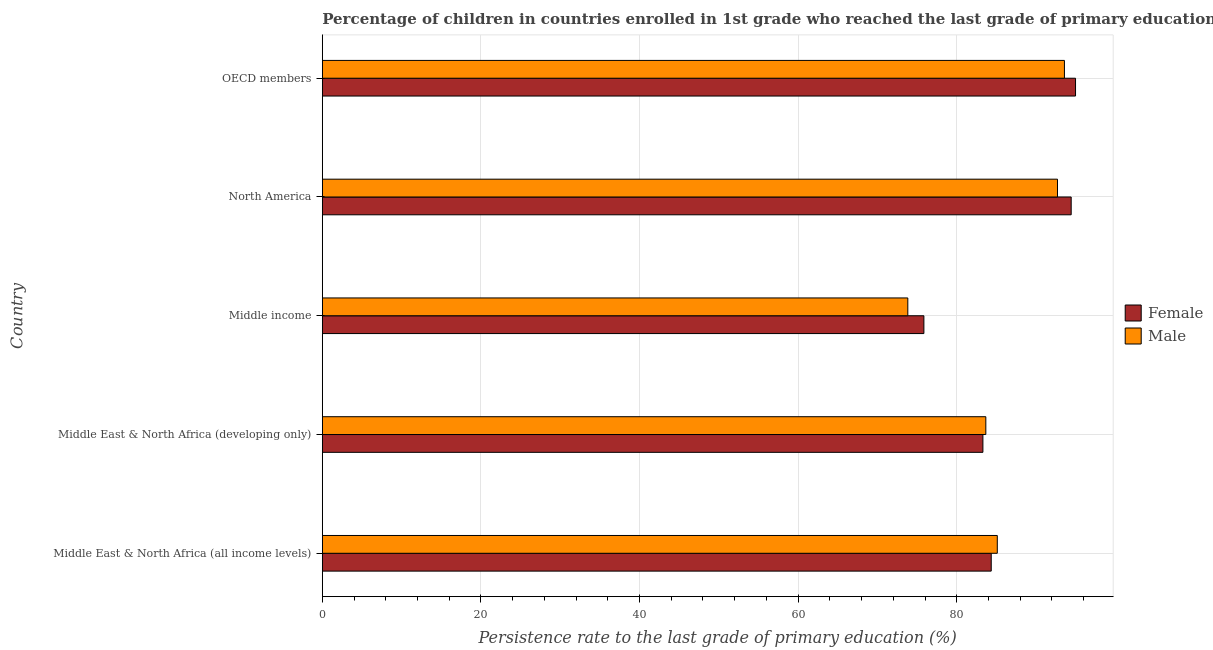How many different coloured bars are there?
Your response must be concise. 2. How many groups of bars are there?
Ensure brevity in your answer.  5. Are the number of bars per tick equal to the number of legend labels?
Your answer should be very brief. Yes. Are the number of bars on each tick of the Y-axis equal?
Your response must be concise. Yes. How many bars are there on the 5th tick from the top?
Provide a short and direct response. 2. In how many cases, is the number of bars for a given country not equal to the number of legend labels?
Make the answer very short. 0. What is the persistence rate of male students in Middle East & North Africa (developing only)?
Your answer should be compact. 83.66. Across all countries, what is the maximum persistence rate of male students?
Your answer should be compact. 93.58. Across all countries, what is the minimum persistence rate of male students?
Offer a terse response. 73.83. In which country was the persistence rate of male students maximum?
Your response must be concise. OECD members. What is the total persistence rate of female students in the graph?
Make the answer very short. 432.91. What is the difference between the persistence rate of male students in North America and that in OECD members?
Your response must be concise. -0.88. What is the difference between the persistence rate of female students in Middle income and the persistence rate of male students in North America?
Your response must be concise. -16.85. What is the average persistence rate of female students per country?
Your answer should be very brief. 86.58. What is the difference between the persistence rate of male students and persistence rate of female students in OECD members?
Ensure brevity in your answer.  -1.4. What is the ratio of the persistence rate of female students in Middle income to that in OECD members?
Give a very brief answer. 0.8. Is the difference between the persistence rate of female students in Middle East & North Africa (developing only) and North America greater than the difference between the persistence rate of male students in Middle East & North Africa (developing only) and North America?
Offer a very short reply. No. What is the difference between the highest and the lowest persistence rate of male students?
Your response must be concise. 19.75. In how many countries, is the persistence rate of female students greater than the average persistence rate of female students taken over all countries?
Your answer should be very brief. 2. What does the 1st bar from the top in Middle income represents?
Provide a short and direct response. Male. What does the 2nd bar from the bottom in Middle income represents?
Provide a succinct answer. Male. Are all the bars in the graph horizontal?
Provide a succinct answer. Yes. How many countries are there in the graph?
Ensure brevity in your answer.  5. What is the difference between two consecutive major ticks on the X-axis?
Ensure brevity in your answer.  20. Does the graph contain any zero values?
Make the answer very short. No. Does the graph contain grids?
Offer a terse response. Yes. How are the legend labels stacked?
Offer a terse response. Vertical. What is the title of the graph?
Your answer should be compact. Percentage of children in countries enrolled in 1st grade who reached the last grade of primary education. Does "Non-resident workers" appear as one of the legend labels in the graph?
Offer a terse response. No. What is the label or title of the X-axis?
Offer a very short reply. Persistence rate to the last grade of primary education (%). What is the label or title of the Y-axis?
Your response must be concise. Country. What is the Persistence rate to the last grade of primary education (%) in Female in Middle East & North Africa (all income levels)?
Keep it short and to the point. 84.35. What is the Persistence rate to the last grade of primary education (%) of Male in Middle East & North Africa (all income levels)?
Provide a succinct answer. 85.11. What is the Persistence rate to the last grade of primary education (%) of Female in Middle East & North Africa (developing only)?
Make the answer very short. 83.3. What is the Persistence rate to the last grade of primary education (%) in Male in Middle East & North Africa (developing only)?
Make the answer very short. 83.66. What is the Persistence rate to the last grade of primary education (%) of Female in Middle income?
Provide a short and direct response. 75.86. What is the Persistence rate to the last grade of primary education (%) of Male in Middle income?
Provide a short and direct response. 73.83. What is the Persistence rate to the last grade of primary education (%) in Female in North America?
Offer a very short reply. 94.43. What is the Persistence rate to the last grade of primary education (%) of Male in North America?
Make the answer very short. 92.7. What is the Persistence rate to the last grade of primary education (%) in Female in OECD members?
Provide a short and direct response. 94.98. What is the Persistence rate to the last grade of primary education (%) of Male in OECD members?
Keep it short and to the point. 93.58. Across all countries, what is the maximum Persistence rate to the last grade of primary education (%) in Female?
Offer a terse response. 94.98. Across all countries, what is the maximum Persistence rate to the last grade of primary education (%) of Male?
Make the answer very short. 93.58. Across all countries, what is the minimum Persistence rate to the last grade of primary education (%) of Female?
Ensure brevity in your answer.  75.86. Across all countries, what is the minimum Persistence rate to the last grade of primary education (%) in Male?
Offer a very short reply. 73.83. What is the total Persistence rate to the last grade of primary education (%) of Female in the graph?
Offer a terse response. 432.91. What is the total Persistence rate to the last grade of primary education (%) in Male in the graph?
Ensure brevity in your answer.  428.89. What is the difference between the Persistence rate to the last grade of primary education (%) in Female in Middle East & North Africa (all income levels) and that in Middle East & North Africa (developing only)?
Make the answer very short. 1.05. What is the difference between the Persistence rate to the last grade of primary education (%) in Male in Middle East & North Africa (all income levels) and that in Middle East & North Africa (developing only)?
Ensure brevity in your answer.  1.45. What is the difference between the Persistence rate to the last grade of primary education (%) in Female in Middle East & North Africa (all income levels) and that in Middle income?
Keep it short and to the point. 8.49. What is the difference between the Persistence rate to the last grade of primary education (%) of Male in Middle East & North Africa (all income levels) and that in Middle income?
Keep it short and to the point. 11.28. What is the difference between the Persistence rate to the last grade of primary education (%) in Female in Middle East & North Africa (all income levels) and that in North America?
Provide a short and direct response. -10.08. What is the difference between the Persistence rate to the last grade of primary education (%) of Male in Middle East & North Africa (all income levels) and that in North America?
Offer a very short reply. -7.59. What is the difference between the Persistence rate to the last grade of primary education (%) of Female in Middle East & North Africa (all income levels) and that in OECD members?
Offer a very short reply. -10.63. What is the difference between the Persistence rate to the last grade of primary education (%) in Male in Middle East & North Africa (all income levels) and that in OECD members?
Offer a very short reply. -8.47. What is the difference between the Persistence rate to the last grade of primary education (%) in Female in Middle East & North Africa (developing only) and that in Middle income?
Your response must be concise. 7.44. What is the difference between the Persistence rate to the last grade of primary education (%) of Male in Middle East & North Africa (developing only) and that in Middle income?
Offer a terse response. 9.84. What is the difference between the Persistence rate to the last grade of primary education (%) of Female in Middle East & North Africa (developing only) and that in North America?
Ensure brevity in your answer.  -11.13. What is the difference between the Persistence rate to the last grade of primary education (%) of Male in Middle East & North Africa (developing only) and that in North America?
Offer a very short reply. -9.04. What is the difference between the Persistence rate to the last grade of primary education (%) of Female in Middle East & North Africa (developing only) and that in OECD members?
Offer a very short reply. -11.68. What is the difference between the Persistence rate to the last grade of primary education (%) of Male in Middle East & North Africa (developing only) and that in OECD members?
Offer a terse response. -9.91. What is the difference between the Persistence rate to the last grade of primary education (%) in Female in Middle income and that in North America?
Provide a succinct answer. -18.57. What is the difference between the Persistence rate to the last grade of primary education (%) of Male in Middle income and that in North America?
Provide a succinct answer. -18.87. What is the difference between the Persistence rate to the last grade of primary education (%) in Female in Middle income and that in OECD members?
Give a very brief answer. -19.12. What is the difference between the Persistence rate to the last grade of primary education (%) in Male in Middle income and that in OECD members?
Provide a succinct answer. -19.75. What is the difference between the Persistence rate to the last grade of primary education (%) in Female in North America and that in OECD members?
Ensure brevity in your answer.  -0.55. What is the difference between the Persistence rate to the last grade of primary education (%) of Male in North America and that in OECD members?
Make the answer very short. -0.88. What is the difference between the Persistence rate to the last grade of primary education (%) in Female in Middle East & North Africa (all income levels) and the Persistence rate to the last grade of primary education (%) in Male in Middle East & North Africa (developing only)?
Provide a succinct answer. 0.68. What is the difference between the Persistence rate to the last grade of primary education (%) in Female in Middle East & North Africa (all income levels) and the Persistence rate to the last grade of primary education (%) in Male in Middle income?
Offer a very short reply. 10.52. What is the difference between the Persistence rate to the last grade of primary education (%) in Female in Middle East & North Africa (all income levels) and the Persistence rate to the last grade of primary education (%) in Male in North America?
Your response must be concise. -8.36. What is the difference between the Persistence rate to the last grade of primary education (%) in Female in Middle East & North Africa (all income levels) and the Persistence rate to the last grade of primary education (%) in Male in OECD members?
Make the answer very short. -9.23. What is the difference between the Persistence rate to the last grade of primary education (%) of Female in Middle East & North Africa (developing only) and the Persistence rate to the last grade of primary education (%) of Male in Middle income?
Offer a very short reply. 9.47. What is the difference between the Persistence rate to the last grade of primary education (%) of Female in Middle East & North Africa (developing only) and the Persistence rate to the last grade of primary education (%) of Male in North America?
Make the answer very short. -9.41. What is the difference between the Persistence rate to the last grade of primary education (%) of Female in Middle East & North Africa (developing only) and the Persistence rate to the last grade of primary education (%) of Male in OECD members?
Provide a succinct answer. -10.28. What is the difference between the Persistence rate to the last grade of primary education (%) of Female in Middle income and the Persistence rate to the last grade of primary education (%) of Male in North America?
Your answer should be very brief. -16.85. What is the difference between the Persistence rate to the last grade of primary education (%) in Female in Middle income and the Persistence rate to the last grade of primary education (%) in Male in OECD members?
Offer a very short reply. -17.72. What is the difference between the Persistence rate to the last grade of primary education (%) of Female in North America and the Persistence rate to the last grade of primary education (%) of Male in OECD members?
Provide a succinct answer. 0.85. What is the average Persistence rate to the last grade of primary education (%) in Female per country?
Provide a short and direct response. 86.58. What is the average Persistence rate to the last grade of primary education (%) in Male per country?
Provide a succinct answer. 85.78. What is the difference between the Persistence rate to the last grade of primary education (%) of Female and Persistence rate to the last grade of primary education (%) of Male in Middle East & North Africa (all income levels)?
Your response must be concise. -0.76. What is the difference between the Persistence rate to the last grade of primary education (%) of Female and Persistence rate to the last grade of primary education (%) of Male in Middle East & North Africa (developing only)?
Make the answer very short. -0.37. What is the difference between the Persistence rate to the last grade of primary education (%) in Female and Persistence rate to the last grade of primary education (%) in Male in Middle income?
Make the answer very short. 2.03. What is the difference between the Persistence rate to the last grade of primary education (%) of Female and Persistence rate to the last grade of primary education (%) of Male in North America?
Make the answer very short. 1.73. What is the difference between the Persistence rate to the last grade of primary education (%) of Female and Persistence rate to the last grade of primary education (%) of Male in OECD members?
Offer a very short reply. 1.4. What is the ratio of the Persistence rate to the last grade of primary education (%) of Female in Middle East & North Africa (all income levels) to that in Middle East & North Africa (developing only)?
Offer a very short reply. 1.01. What is the ratio of the Persistence rate to the last grade of primary education (%) of Male in Middle East & North Africa (all income levels) to that in Middle East & North Africa (developing only)?
Provide a short and direct response. 1.02. What is the ratio of the Persistence rate to the last grade of primary education (%) in Female in Middle East & North Africa (all income levels) to that in Middle income?
Provide a short and direct response. 1.11. What is the ratio of the Persistence rate to the last grade of primary education (%) of Male in Middle East & North Africa (all income levels) to that in Middle income?
Your answer should be very brief. 1.15. What is the ratio of the Persistence rate to the last grade of primary education (%) of Female in Middle East & North Africa (all income levels) to that in North America?
Your response must be concise. 0.89. What is the ratio of the Persistence rate to the last grade of primary education (%) of Male in Middle East & North Africa (all income levels) to that in North America?
Keep it short and to the point. 0.92. What is the ratio of the Persistence rate to the last grade of primary education (%) of Female in Middle East & North Africa (all income levels) to that in OECD members?
Offer a very short reply. 0.89. What is the ratio of the Persistence rate to the last grade of primary education (%) of Male in Middle East & North Africa (all income levels) to that in OECD members?
Your answer should be compact. 0.91. What is the ratio of the Persistence rate to the last grade of primary education (%) of Female in Middle East & North Africa (developing only) to that in Middle income?
Keep it short and to the point. 1.1. What is the ratio of the Persistence rate to the last grade of primary education (%) of Male in Middle East & North Africa (developing only) to that in Middle income?
Provide a short and direct response. 1.13. What is the ratio of the Persistence rate to the last grade of primary education (%) of Female in Middle East & North Africa (developing only) to that in North America?
Your response must be concise. 0.88. What is the ratio of the Persistence rate to the last grade of primary education (%) in Male in Middle East & North Africa (developing only) to that in North America?
Offer a very short reply. 0.9. What is the ratio of the Persistence rate to the last grade of primary education (%) of Female in Middle East & North Africa (developing only) to that in OECD members?
Ensure brevity in your answer.  0.88. What is the ratio of the Persistence rate to the last grade of primary education (%) in Male in Middle East & North Africa (developing only) to that in OECD members?
Offer a terse response. 0.89. What is the ratio of the Persistence rate to the last grade of primary education (%) of Female in Middle income to that in North America?
Ensure brevity in your answer.  0.8. What is the ratio of the Persistence rate to the last grade of primary education (%) in Male in Middle income to that in North America?
Provide a succinct answer. 0.8. What is the ratio of the Persistence rate to the last grade of primary education (%) of Female in Middle income to that in OECD members?
Your response must be concise. 0.8. What is the ratio of the Persistence rate to the last grade of primary education (%) in Male in Middle income to that in OECD members?
Keep it short and to the point. 0.79. What is the ratio of the Persistence rate to the last grade of primary education (%) of Female in North America to that in OECD members?
Ensure brevity in your answer.  0.99. What is the ratio of the Persistence rate to the last grade of primary education (%) of Male in North America to that in OECD members?
Your response must be concise. 0.99. What is the difference between the highest and the second highest Persistence rate to the last grade of primary education (%) in Female?
Keep it short and to the point. 0.55. What is the difference between the highest and the second highest Persistence rate to the last grade of primary education (%) in Male?
Give a very brief answer. 0.88. What is the difference between the highest and the lowest Persistence rate to the last grade of primary education (%) in Female?
Provide a short and direct response. 19.12. What is the difference between the highest and the lowest Persistence rate to the last grade of primary education (%) in Male?
Provide a succinct answer. 19.75. 